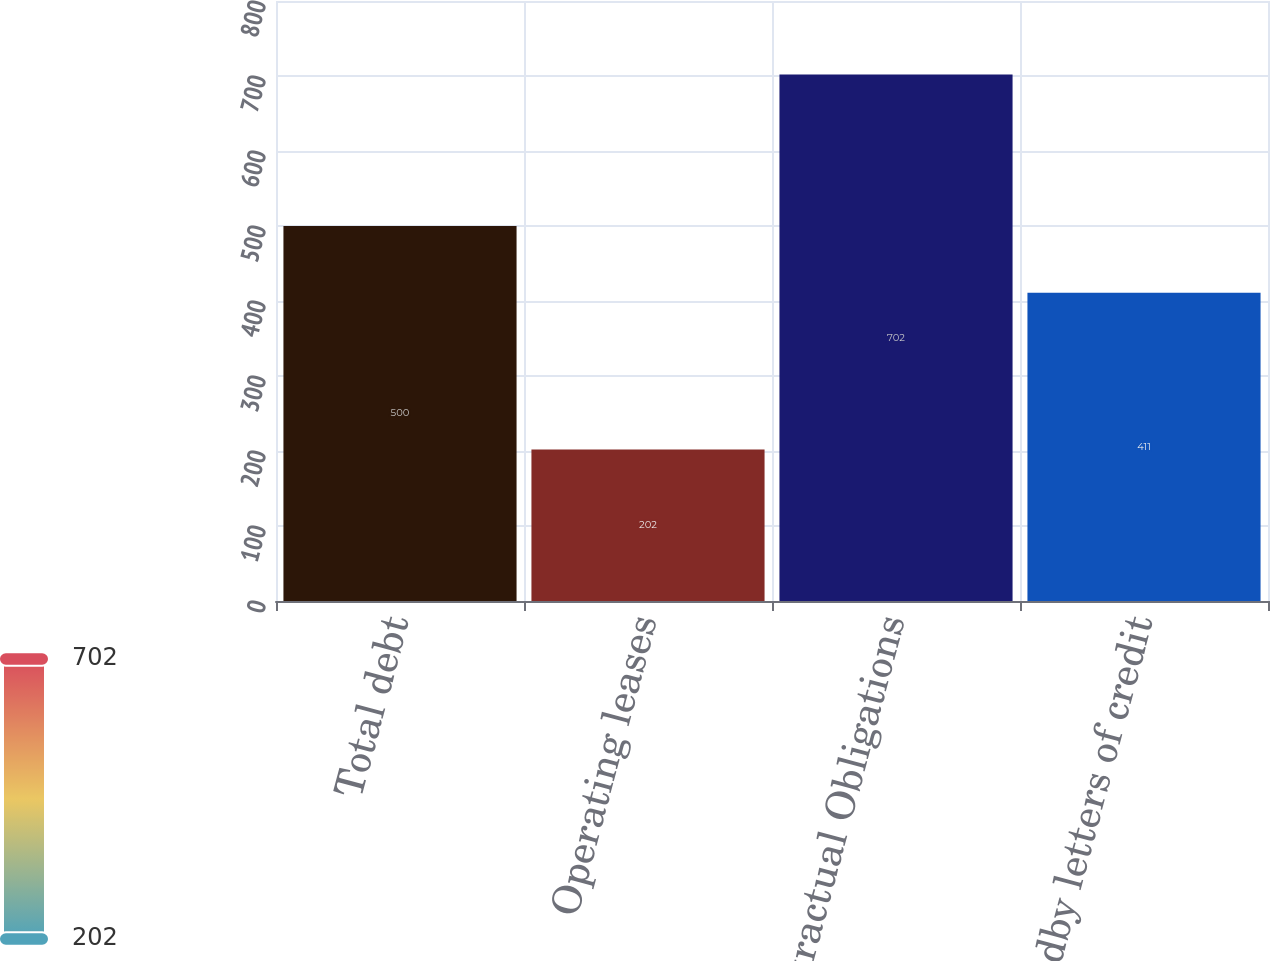Convert chart. <chart><loc_0><loc_0><loc_500><loc_500><bar_chart><fcel>Total debt<fcel>Operating leases<fcel>Total Contractual Obligations<fcel>Standby letters of credit<nl><fcel>500<fcel>202<fcel>702<fcel>411<nl></chart> 